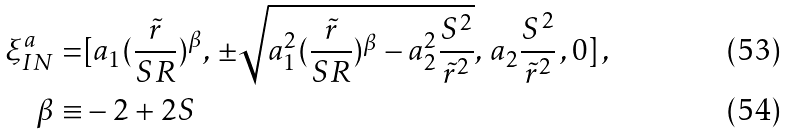Convert formula to latex. <formula><loc_0><loc_0><loc_500><loc_500>\xi _ { I N } ^ { a } = & [ a _ { 1 } ( \frac { \tilde { r } } { S R } ) ^ { \beta } , \, \pm \sqrt { a _ { 1 } ^ { 2 } ( \frac { \tilde { r } } { S R } ) ^ { \beta } - a _ { 2 } ^ { 2 } \frac { S ^ { 2 } } { \tilde { r } ^ { 2 } } } , \, a _ { 2 } \frac { S ^ { 2 } } { \tilde { r } ^ { 2 } } \, , 0 ] \, , \\ \beta \equiv & - 2 + 2 S</formula> 